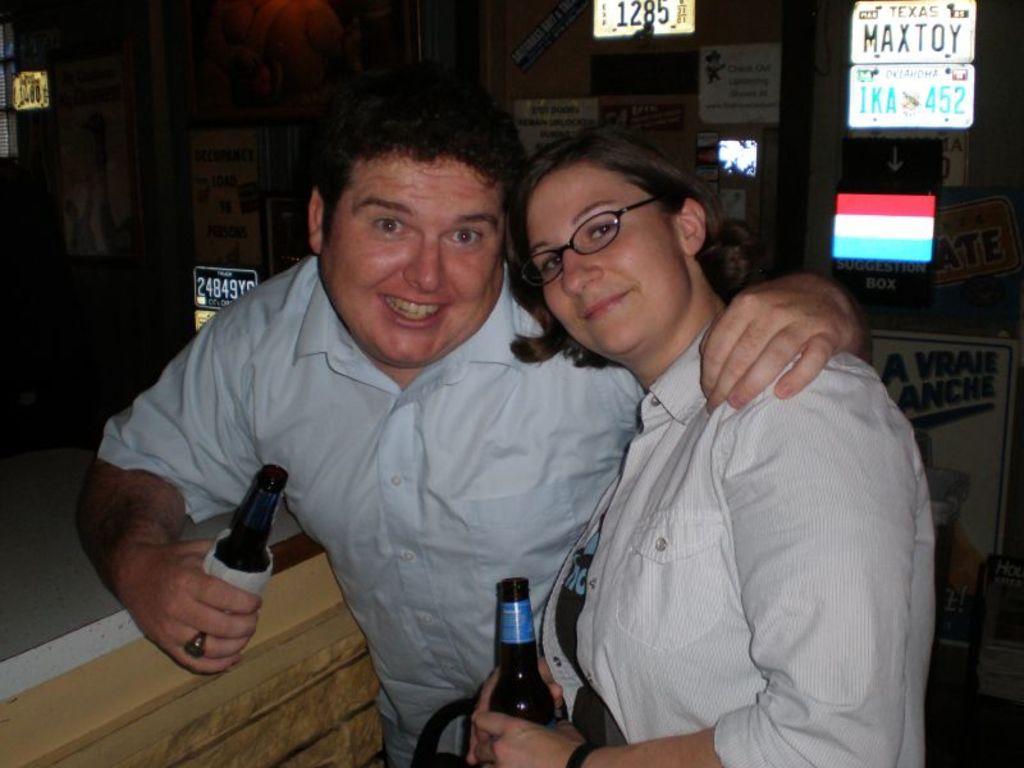Can you describe this image briefly? In this picture we can see there are two persons holding the bottles. Behind the people, there are registration plates and some objects. 